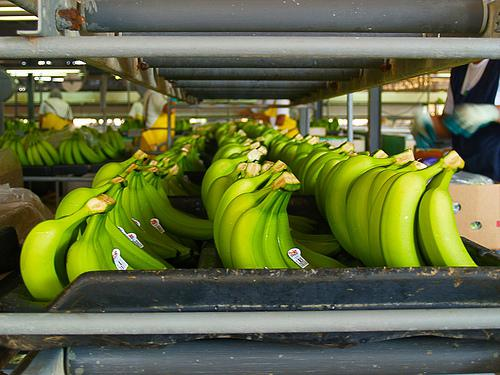Question: what is on the people's heads?
Choices:
A. Hats.
B. Hairnets.
C. Sunglasses.
D. Wigs.
Answer with the letter. Answer: B Question: what are the white things on the fruit?
Choices:
A. Stickers.
B. Bugs.
C. Pictures.
D. Price tags.
Answer with the letter. Answer: A Question: how many holes are in the box?
Choices:
A. Three.
B. Two.
C. One.
D. Zero.
Answer with the letter. Answer: B Question: what kind of fruit is this?
Choices:
A. Strawberry.
B. Apple.
C. Blueberry.
D. Banana.
Answer with the letter. Answer: D 